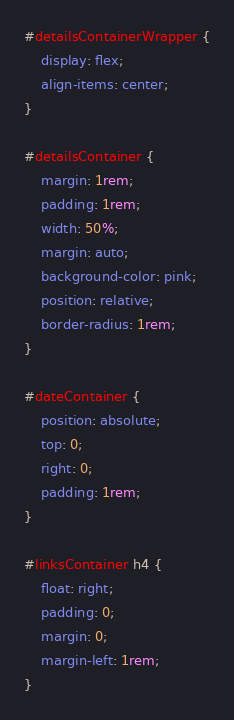<code> <loc_0><loc_0><loc_500><loc_500><_CSS_>#detailsContainerWrapper {
	display: flex;
	align-items: center;
}

#detailsContainer {
	margin: 1rem;
	padding: 1rem;
	width: 50%;
	margin: auto;
	background-color: pink;
	position: relative;
	border-radius: 1rem;
}

#dateContainer {
	position: absolute;
	top: 0;
	right: 0;
	padding: 1rem;
}

#linksContainer h4 {
	float: right;
	padding: 0;
	margin: 0;
	margin-left: 1rem;
}
</code> 